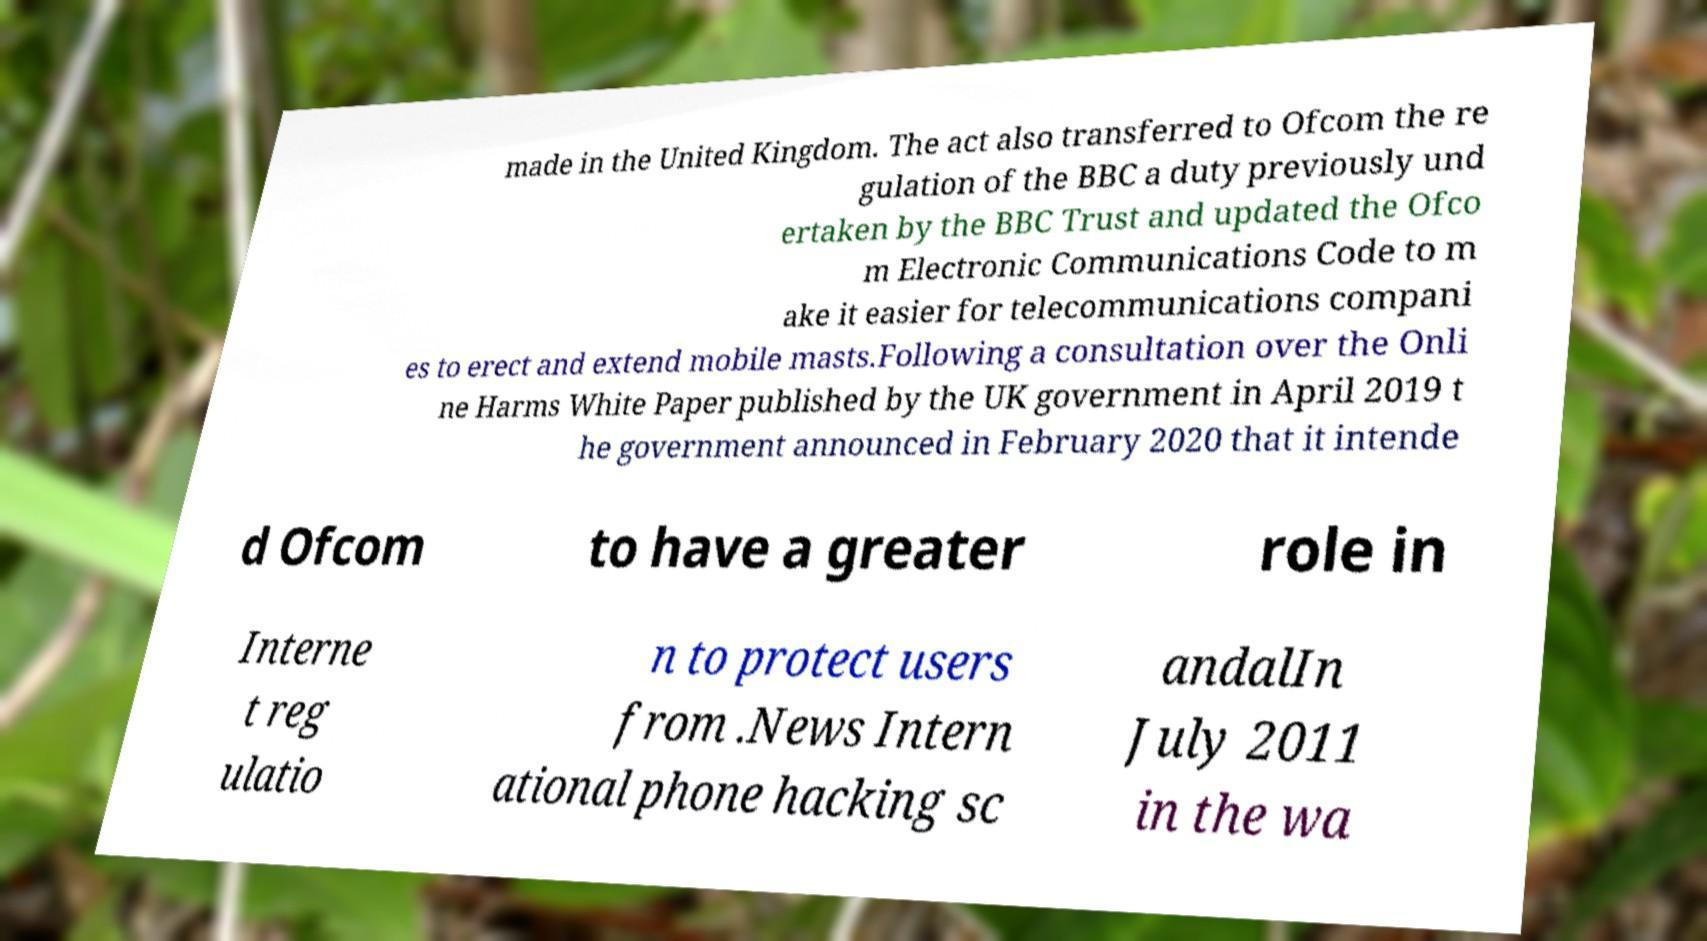Please read and relay the text visible in this image. What does it say? made in the United Kingdom. The act also transferred to Ofcom the re gulation of the BBC a duty previously und ertaken by the BBC Trust and updated the Ofco m Electronic Communications Code to m ake it easier for telecommunications compani es to erect and extend mobile masts.Following a consultation over the Onli ne Harms White Paper published by the UK government in April 2019 t he government announced in February 2020 that it intende d Ofcom to have a greater role in Interne t reg ulatio n to protect users from .News Intern ational phone hacking sc andalIn July 2011 in the wa 